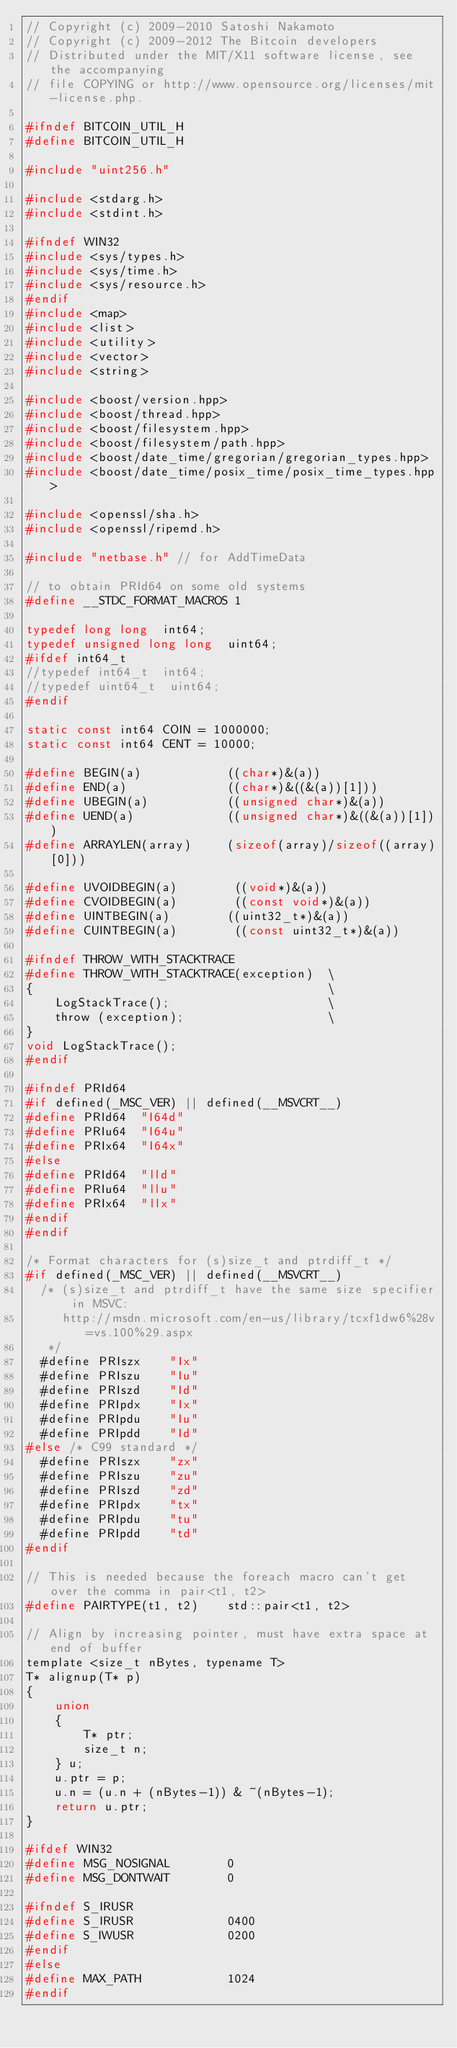Convert code to text. <code><loc_0><loc_0><loc_500><loc_500><_C_>// Copyright (c) 2009-2010 Satoshi Nakamoto
// Copyright (c) 2009-2012 The Bitcoin developers
// Distributed under the MIT/X11 software license, see the accompanying
// file COPYING or http://www.opensource.org/licenses/mit-license.php.

#ifndef BITCOIN_UTIL_H
#define BITCOIN_UTIL_H

#include "uint256.h"

#include <stdarg.h>
#include <stdint.h>

#ifndef WIN32
#include <sys/types.h>
#include <sys/time.h>
#include <sys/resource.h>
#endif
#include <map>
#include <list>
#include <utility>
#include <vector>
#include <string>

#include <boost/version.hpp>
#include <boost/thread.hpp>
#include <boost/filesystem.hpp>
#include <boost/filesystem/path.hpp>
#include <boost/date_time/gregorian/gregorian_types.hpp>
#include <boost/date_time/posix_time/posix_time_types.hpp>

#include <openssl/sha.h>
#include <openssl/ripemd.h>

#include "netbase.h" // for AddTimeData

// to obtain PRId64 on some old systems
#define __STDC_FORMAT_MACROS 1

typedef long long  int64;
typedef unsigned long long  uint64;
#ifdef int64_t
//typedef int64_t  int64;
//typedef uint64_t  uint64;
#endif

static const int64 COIN = 1000000;
static const int64 CENT = 10000;

#define BEGIN(a)            ((char*)&(a))
#define END(a)              ((char*)&((&(a))[1]))
#define UBEGIN(a)           ((unsigned char*)&(a))
#define UEND(a)             ((unsigned char*)&((&(a))[1]))
#define ARRAYLEN(array)     (sizeof(array)/sizeof((array)[0]))

#define UVOIDBEGIN(a)        ((void*)&(a))
#define CVOIDBEGIN(a)        ((const void*)&(a))
#define UINTBEGIN(a)        ((uint32_t*)&(a))
#define CUINTBEGIN(a)        ((const uint32_t*)&(a))

#ifndef THROW_WITH_STACKTRACE
#define THROW_WITH_STACKTRACE(exception)  \
{                                         \
    LogStackTrace();                      \
    throw (exception);                    \
}
void LogStackTrace();
#endif

#ifndef PRId64
#if defined(_MSC_VER) || defined(__MSVCRT__)
#define PRId64  "I64d"
#define PRIu64  "I64u"
#define PRIx64  "I64x"
#else
#define PRId64  "lld"
#define PRIu64  "llu"
#define PRIx64  "llx"
#endif
#endif

/* Format characters for (s)size_t and ptrdiff_t */
#if defined(_MSC_VER) || defined(__MSVCRT__)
  /* (s)size_t and ptrdiff_t have the same size specifier in MSVC:
     http://msdn.microsoft.com/en-us/library/tcxf1dw6%28v=vs.100%29.aspx
   */
  #define PRIszx    "Ix"
  #define PRIszu    "Iu"
  #define PRIszd    "Id"
  #define PRIpdx    "Ix"
  #define PRIpdu    "Iu"
  #define PRIpdd    "Id"
#else /* C99 standard */
  #define PRIszx    "zx"
  #define PRIszu    "zu"
  #define PRIszd    "zd"
  #define PRIpdx    "tx"
  #define PRIpdu    "tu"
  #define PRIpdd    "td"
#endif

// This is needed because the foreach macro can't get over the comma in pair<t1, t2>
#define PAIRTYPE(t1, t2)    std::pair<t1, t2>

// Align by increasing pointer, must have extra space at end of buffer
template <size_t nBytes, typename T>
T* alignup(T* p)
{
    union
    {
        T* ptr;
        size_t n;
    } u;
    u.ptr = p;
    u.n = (u.n + (nBytes-1)) & ~(nBytes-1);
    return u.ptr;
}

#ifdef WIN32
#define MSG_NOSIGNAL        0
#define MSG_DONTWAIT        0

#ifndef S_IRUSR
#define S_IRUSR             0400
#define S_IWUSR             0200
#endif
#else
#define MAX_PATH            1024
#endif
</code> 